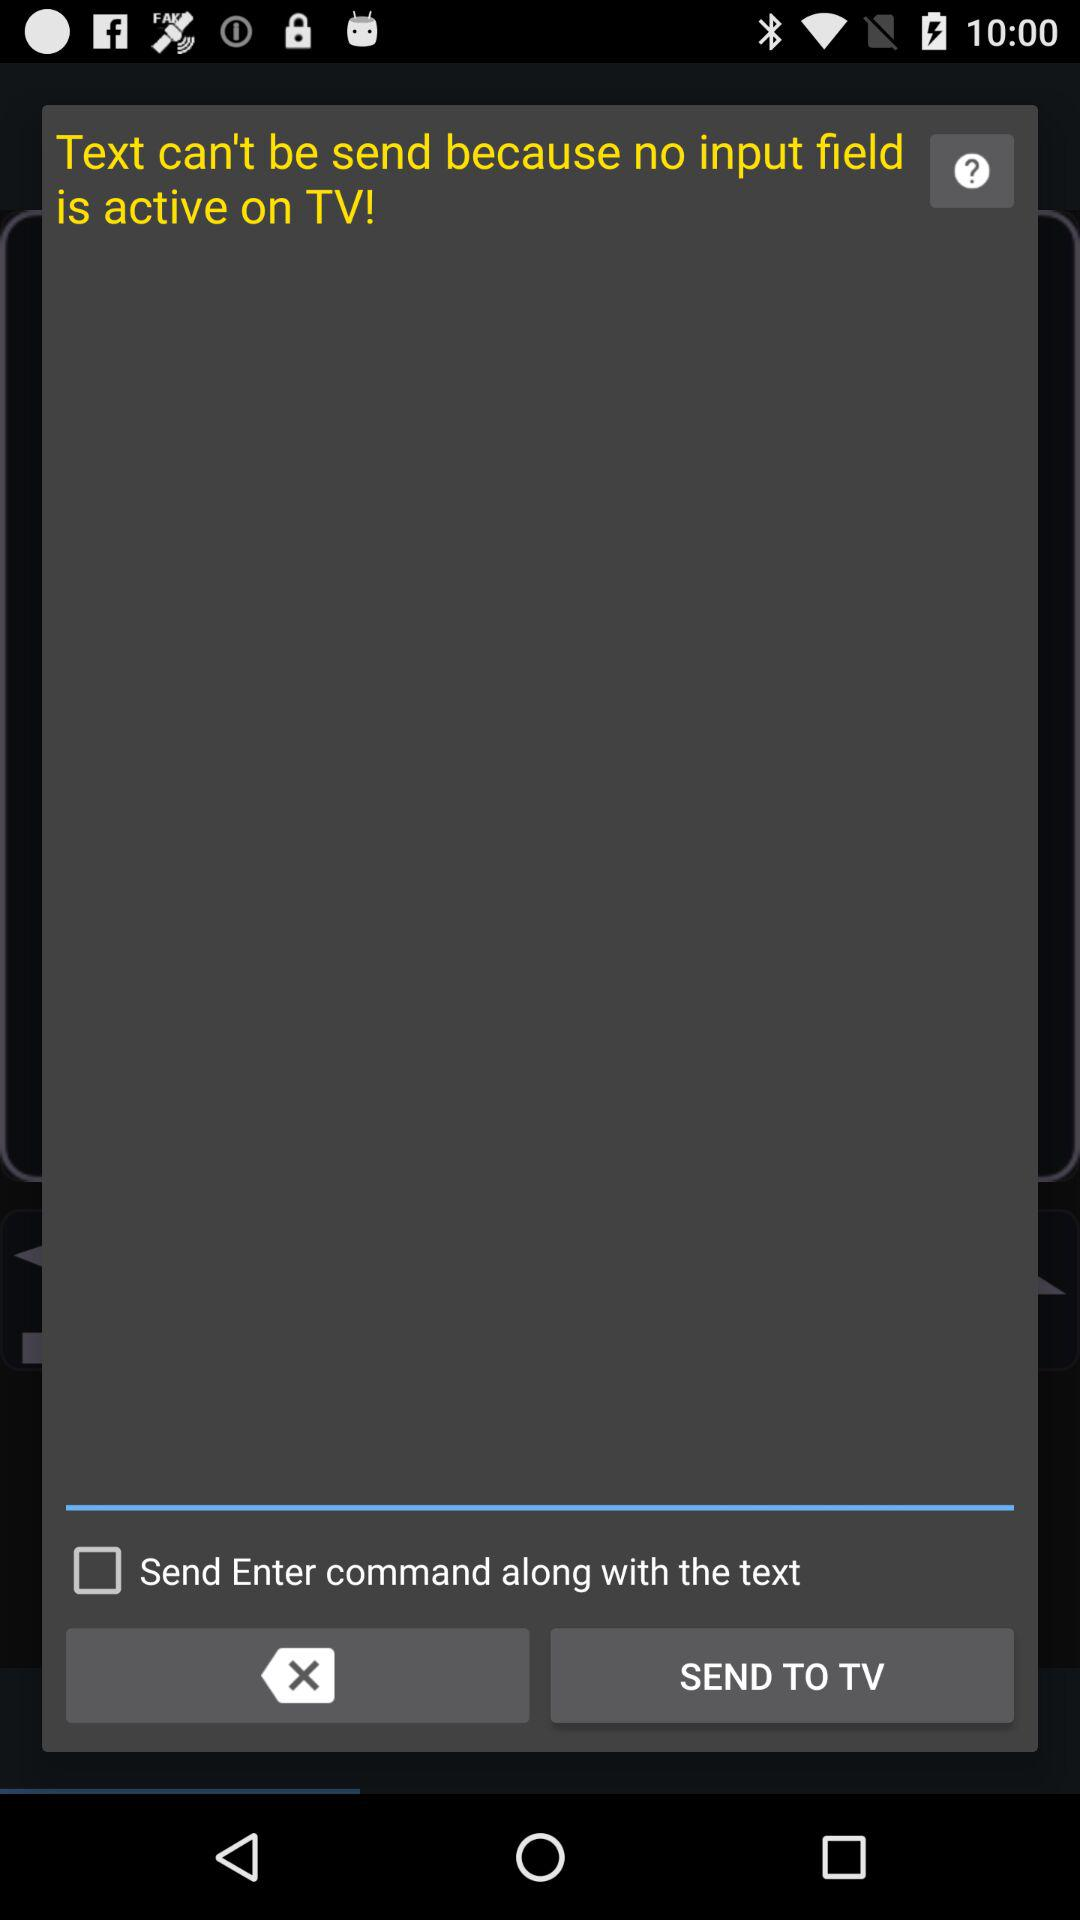What is the status of the "Send Enter command along with the text"? The status is "off". 